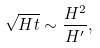Convert formula to latex. <formula><loc_0><loc_0><loc_500><loc_500>\sqrt { H t } \sim \frac { H ^ { 2 } } { H ^ { \prime } } ,</formula> 